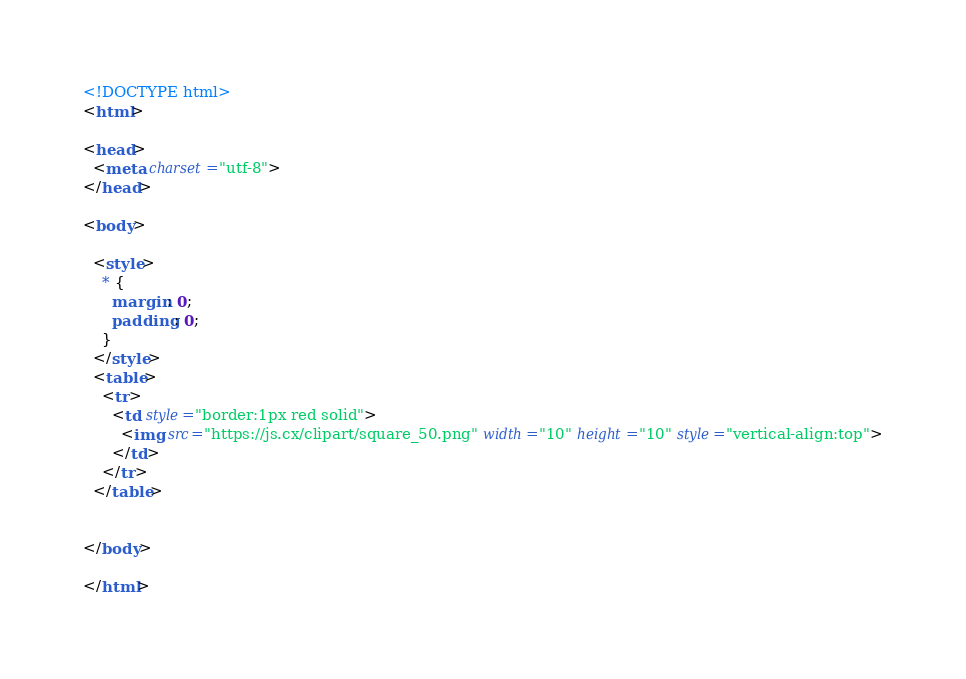Convert code to text. <code><loc_0><loc_0><loc_500><loc_500><_HTML_><!DOCTYPE html>
<html>

<head>
  <meta charset="utf-8">
</head>

<body>

  <style>
    * {
      margin: 0;
      padding: 0;
    }
  </style>
  <table>
    <tr>
      <td style="border:1px red solid">
        <img src="https://js.cx/clipart/square_50.png" width="10" height="10" style="vertical-align:top">
      </td>
    </tr>
  </table>


</body>

</html></code> 